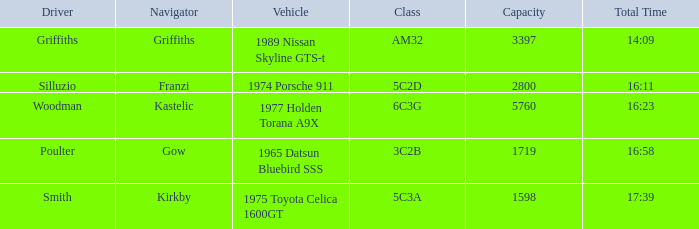What kind of vehicle is categorized under the 6c3g class? 1977 Holden Torana A9X. 